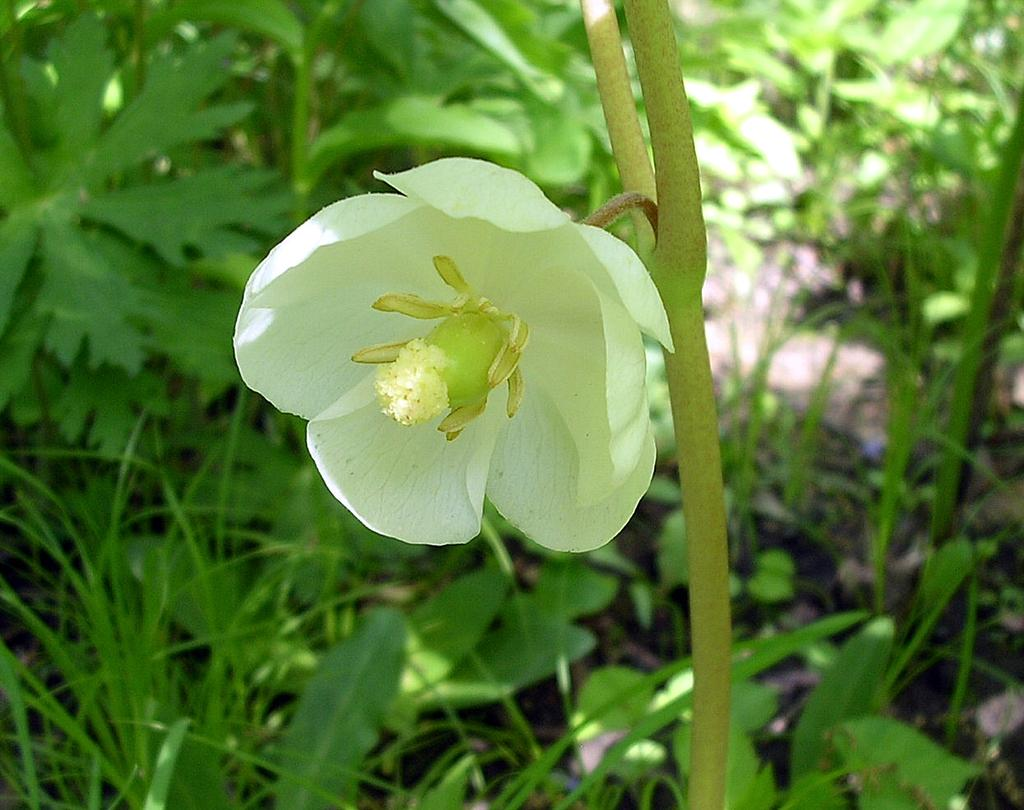What type of flower can be seen on the plant in the image? There is a white flower on a plant in the image. What type of vegetation is at the bottom of the image? There is grass at the bottom of the image. What can be seen in the background of the image? There are plants with green leaves in the background of the image. What type of fuel is being used to teach the rail in the image? There is no rail, teaching, or fuel present in the image. 